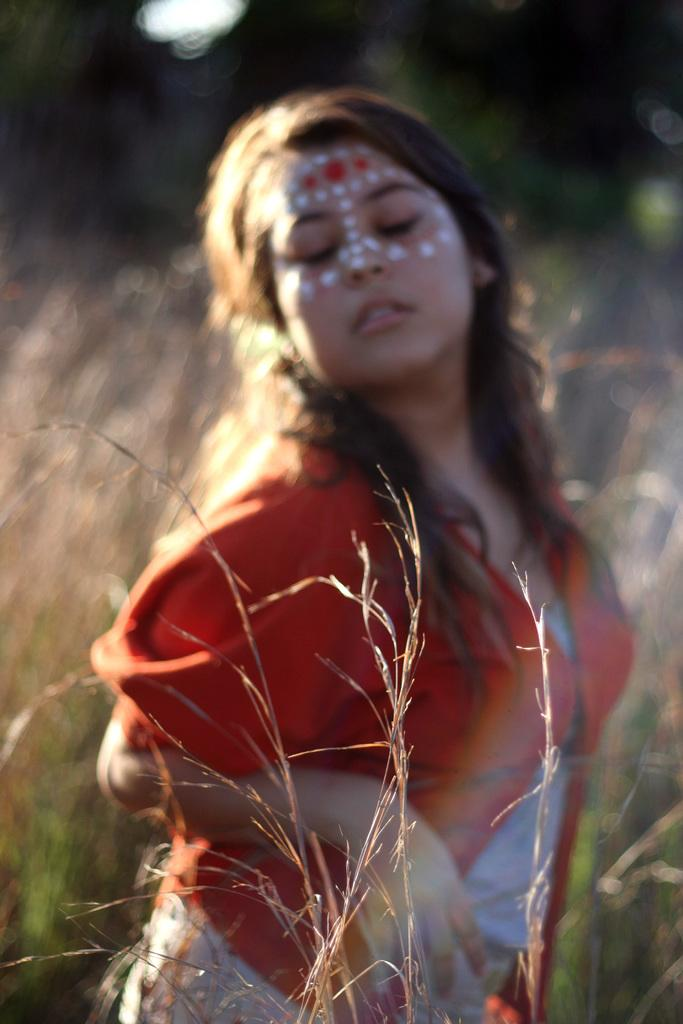What is in the foreground of the image? There is grass in the foreground of the image. What is the woman in the image doing? The woman is standing and closing her eyes. Can you describe the background of the image? The background of the image is blurred. What type of wing is visible on the woman in the image? There is no wing visible on the woman in the image. What other plants can be seen in the image besides the grass in the foreground? There is no other plant visible in the image besides the grass in the foreground. 